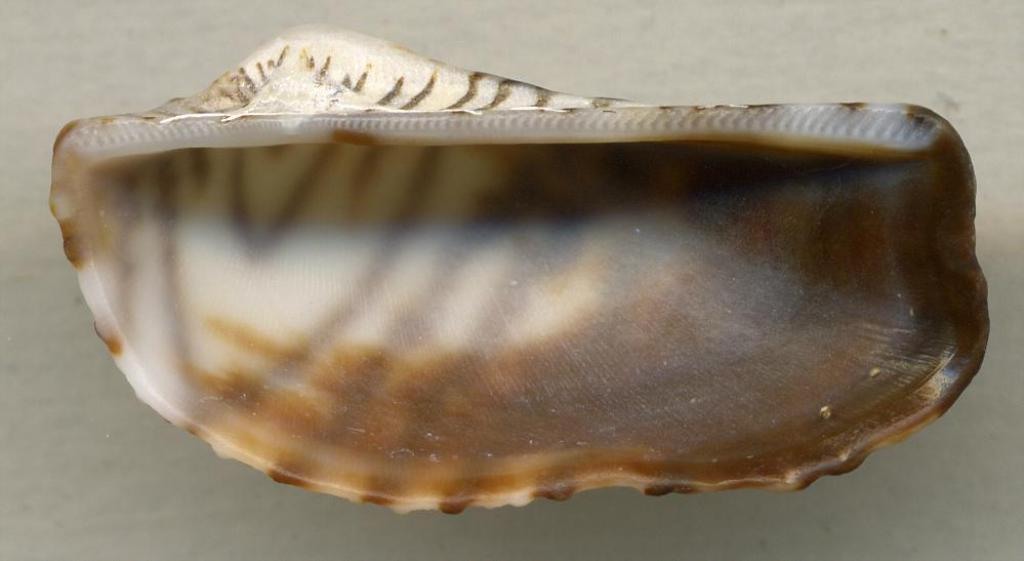What is the main subject in the center of the image? There is a shell in the center of the image. Can you describe the possible surface beneath the shell? There might be a floor at the bottom of the image. What type of shoe is visible in the image? There is no shoe present in the image; it only features a shell and possibly a floor. 